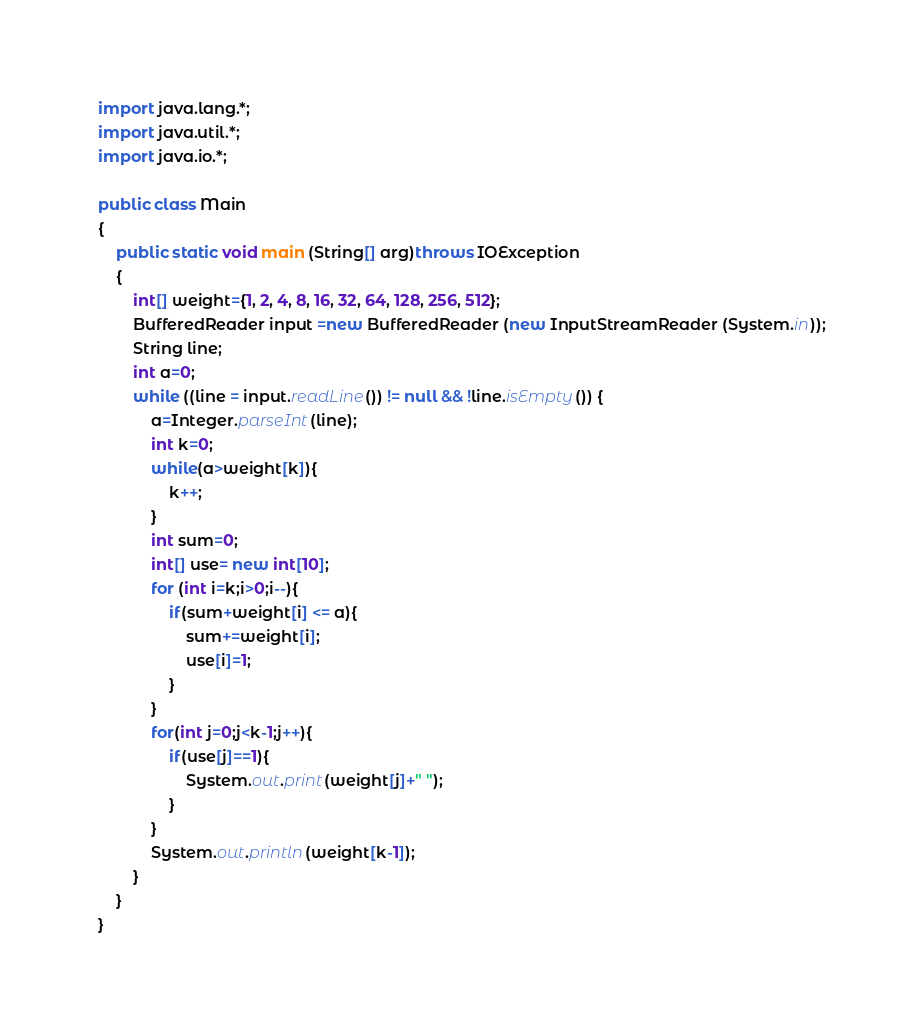Convert code to text. <code><loc_0><loc_0><loc_500><loc_500><_Java_>import java.lang.*;
import java.util.*;
import java.io.*;

public class Main
{
	public static void main (String[] arg)throws IOException
	{
		int[] weight={1, 2, 4, 8, 16, 32, 64, 128, 256, 512};
		BufferedReader input =new BufferedReader (new InputStreamReader (System.in));
		String line;
		int a=0;
		while ((line = input.readLine()) != null && !line.isEmpty()) {
			a=Integer.parseInt(line);
			int k=0;
			while(a>weight[k]){
				k++;	
			}
			int sum=0;
			int[] use= new int[10];
			for (int i=k;i>0;i--){
				if(sum+weight[i] <= a){
					sum+=weight[i];
					use[i]=1;
				}
			}
			for(int j=0;j<k-1;j++){
				if(use[j]==1){
					System.out.print(weight[j]+" ");
				}
			}
			System.out.println(weight[k-1]);
		}
	}
}	</code> 